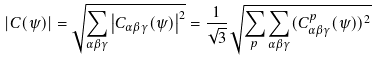<formula> <loc_0><loc_0><loc_500><loc_500>\left | C ( \psi ) \right | = \sqrt { \underset { \alpha \beta \gamma } { \sum } \left | C _ { \alpha \beta \gamma } ( \psi ) \right | ^ { 2 } } = \frac { 1 } { \sqrt { 3 } } \sqrt { \sum _ { p } \underset { \alpha \beta \gamma } { \sum } ( C _ { \alpha \beta \gamma } ^ { p } ( \psi ) ) ^ { 2 } }</formula> 